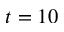Convert formula to latex. <formula><loc_0><loc_0><loc_500><loc_500>t = 1 0</formula> 